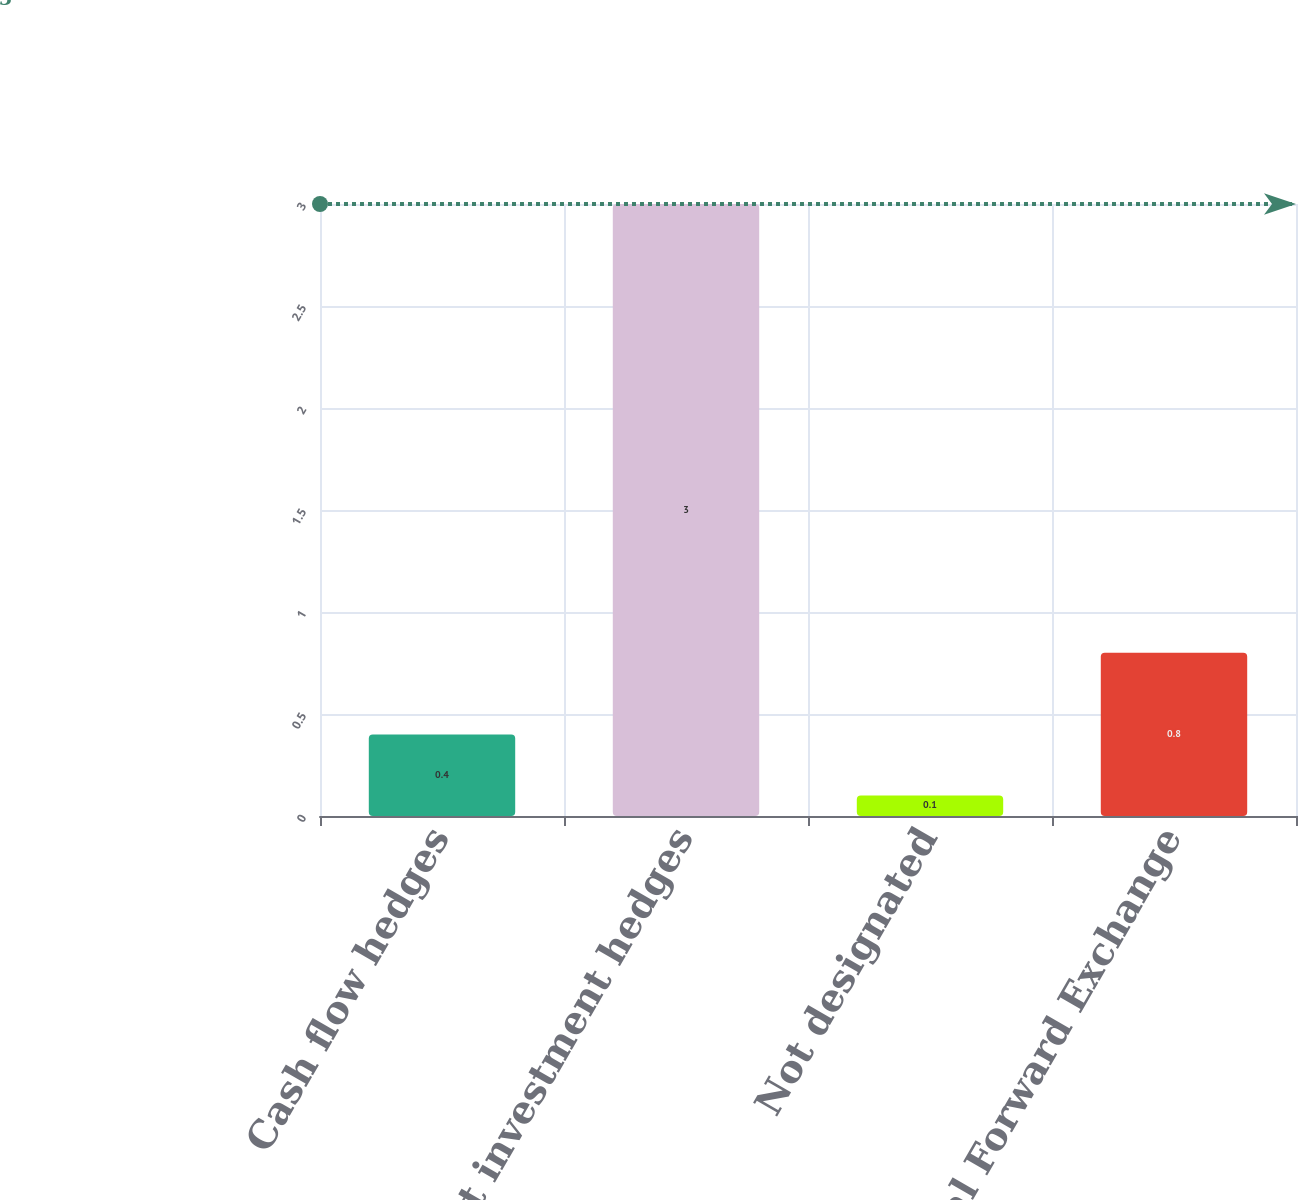Convert chart. <chart><loc_0><loc_0><loc_500><loc_500><bar_chart><fcel>Cash flow hedges<fcel>Net investment hedges<fcel>Not designated<fcel>Total Forward Exchange<nl><fcel>0.4<fcel>3<fcel>0.1<fcel>0.8<nl></chart> 